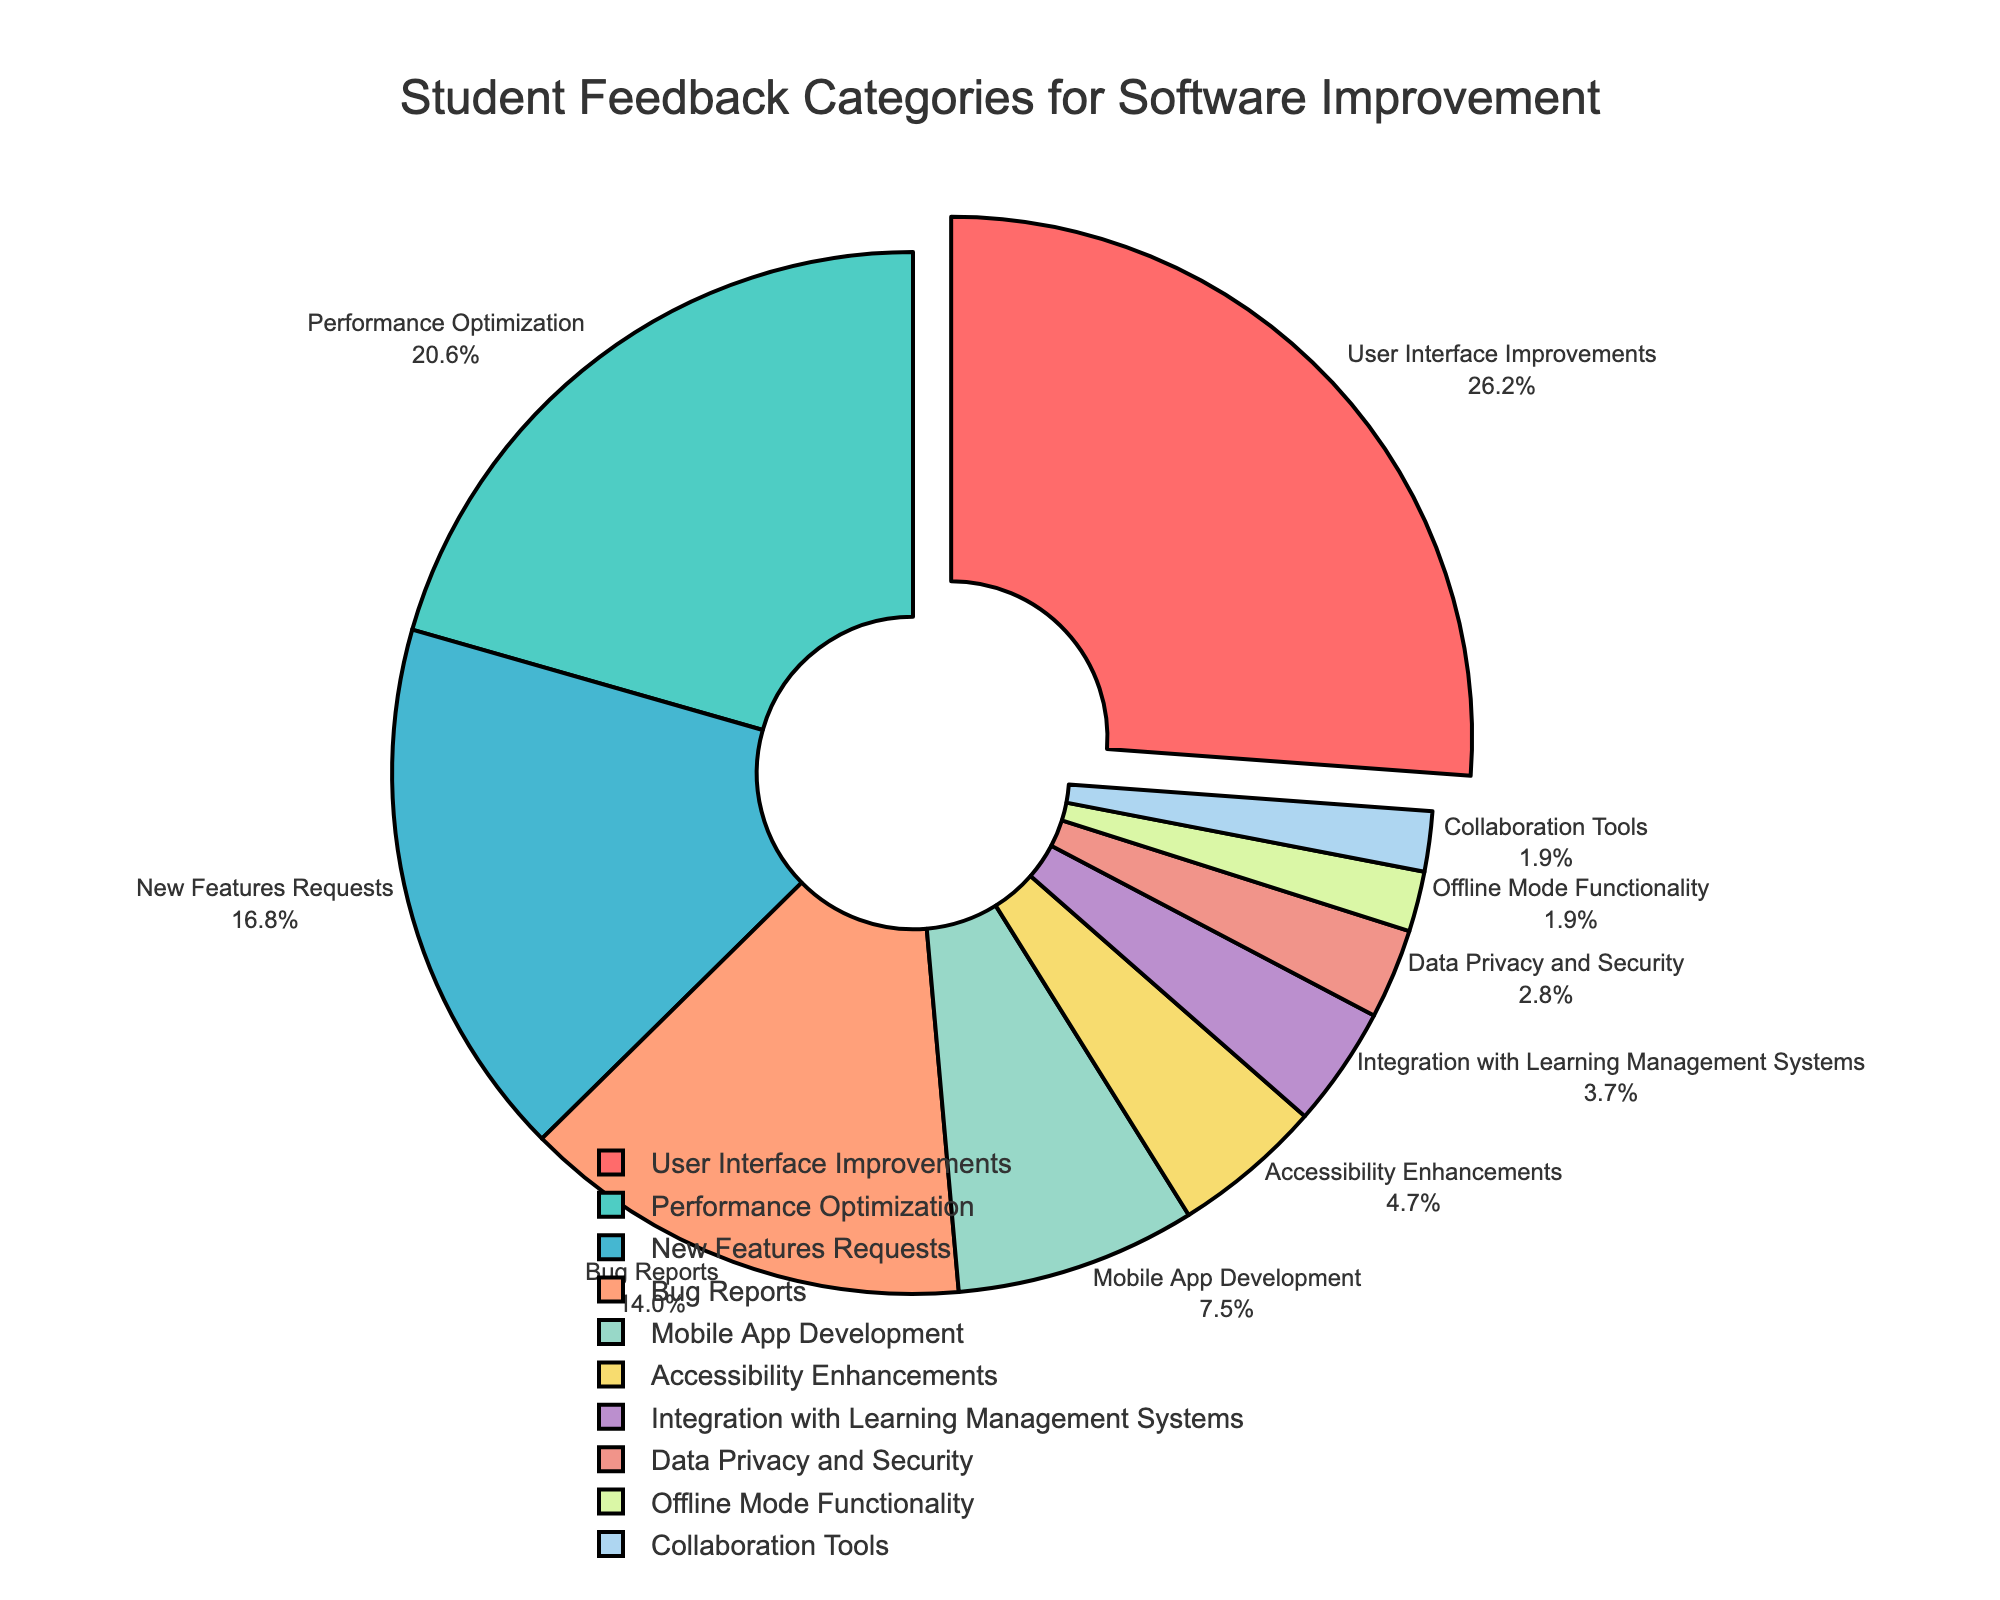What's the category with the highest percentage of student feedback? Look for the label with the largest slice, which is "User Interface Improvements" at 28%.
Answer: User Interface Improvements Which category has the lowest percentage of student feedback? Identify the smallest slice, which is "Collaboration Tools" at 2%.
Answer: Collaboration Tools How much higher is the percentage of "User Interface Improvements" compared to "Bug Reports"? Subtract the percentage of "Bug Reports" (15%) from "User Interface Improvements" (28%). The difference is 28% - 15% = 13%.
Answer: 13% What is the combined percentage of "Mobile App Development" and "Performance Optimization"? Add the percentages of "Mobile App Development" (8%) and "Performance Optimization" (22%). The sum is 8% + 22% = 30%.
Answer: 30% Which categories combined make up more than 50% of the feedback? Sum the categories in descending order until the total exceeds 50%. "User Interface Improvements" (28%) + "Performance Optimization" (22%) = 50%, which already meets the condition.
Answer: User Interface Improvements, Performance Optimization Are there more requests for "New Features" or "Accessibility Enhancements"? Compare the percentages of "New Features Requests" (18%) and "Accessibility Enhancements" (5%). 18% is greater than 5%.
Answer: New Features Requests What's the difference in feedback percentage between "Integration with Learning Management Systems" and "Data Privacy and Security"? Subtract the percentage of "Data Privacy and Security" (3%) from "Integration with Learning Management Systems" (4%). The difference is 4% - 3% = 1%.
Answer: 1% What percentage of feedback does the "Bug Reports" category represent compared to the total? The "Bug Reports" category represents 15% of the total feedback.
Answer: 15% If you combine "Offline Mode Functionality" and "Collaboration Tools," do they have a higher percentage than "Data Privacy and Security"? Add "Offline Mode Functionality" (2%) and "Collaboration Tools" (2%) to get 4%. Compare it with "Data Privacy and Security" (3%). 4% is greater than 3%.
Answer: Yes How much more feedback does "Mobile App Development" receive compared to "Offline Mode Functionality"? Subtract the percentage of "Offline Mode Functionality" (2%) from "Mobile App Development" (8%). The difference is 8% - 2% = 6%.
Answer: 6% 